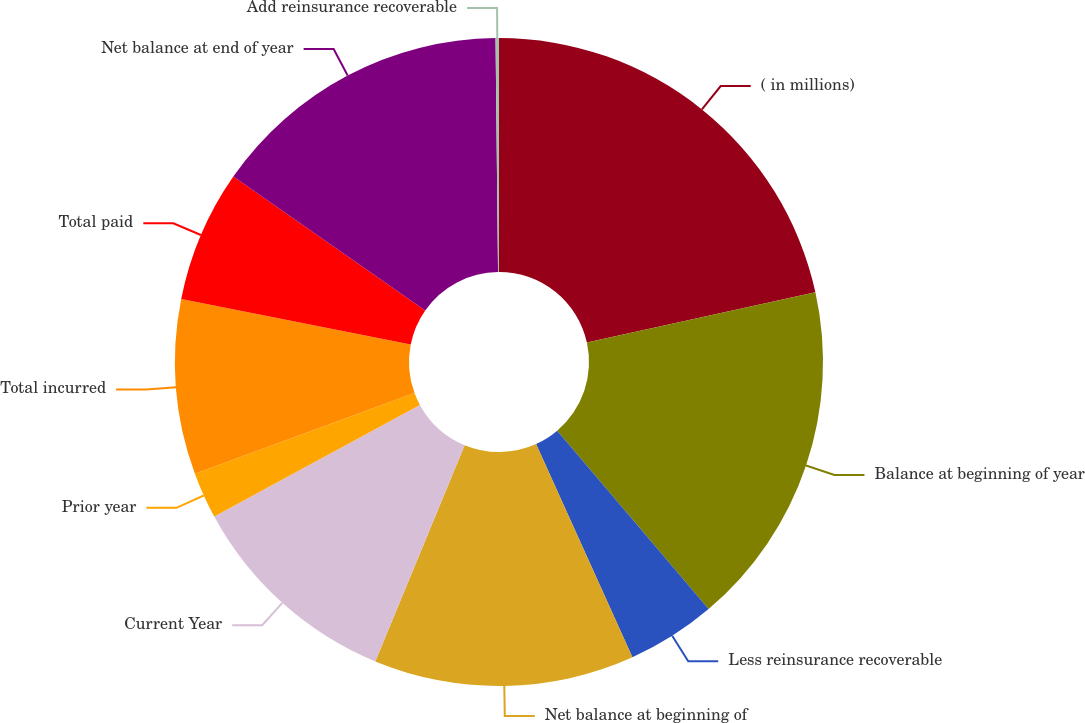<chart> <loc_0><loc_0><loc_500><loc_500><pie_chart><fcel>( in millions)<fcel>Balance at beginning of year<fcel>Less reinsurance recoverable<fcel>Net balance at beginning of<fcel>Current Year<fcel>Prior year<fcel>Total incurred<fcel>Total paid<fcel>Net balance at end of year<fcel>Add reinsurance recoverable<nl><fcel>21.54%<fcel>17.26%<fcel>4.44%<fcel>12.99%<fcel>10.85%<fcel>2.31%<fcel>8.72%<fcel>6.58%<fcel>15.13%<fcel>0.17%<nl></chart> 